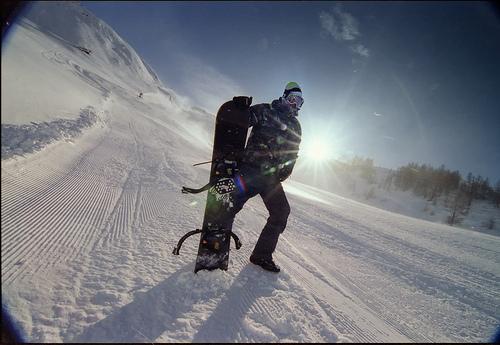Is the man a sportsman?
Keep it brief. Yes. Where is the snowboard?
Write a very short answer. In his hand. What sort of lens was this photo taken with?
Give a very brief answer. Fisheye. 